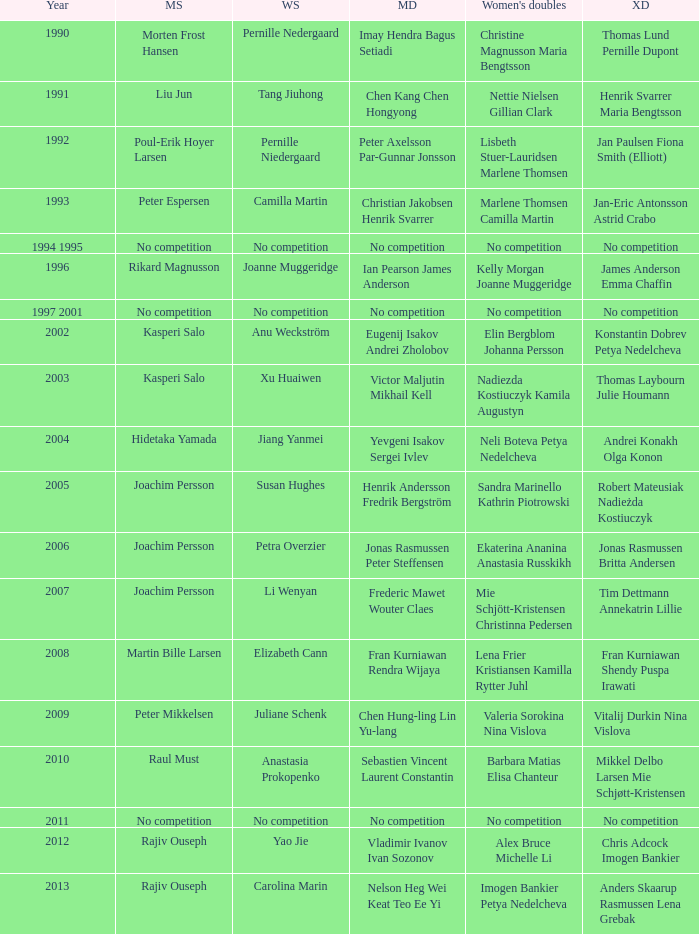Who won the Mixed doubles when Juliane Schenk won the Women's Singles? Vitalij Durkin Nina Vislova. 